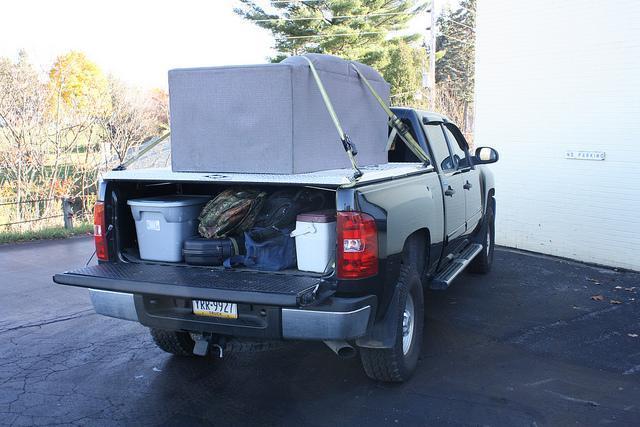Is the statement "The couch is on top of the truck." accurate regarding the image?
Answer yes or no. Yes. Is "The truck is beneath the couch." an appropriate description for the image?
Answer yes or no. Yes. Is the caption "The couch is on the truck." a true representation of the image?
Answer yes or no. Yes. 